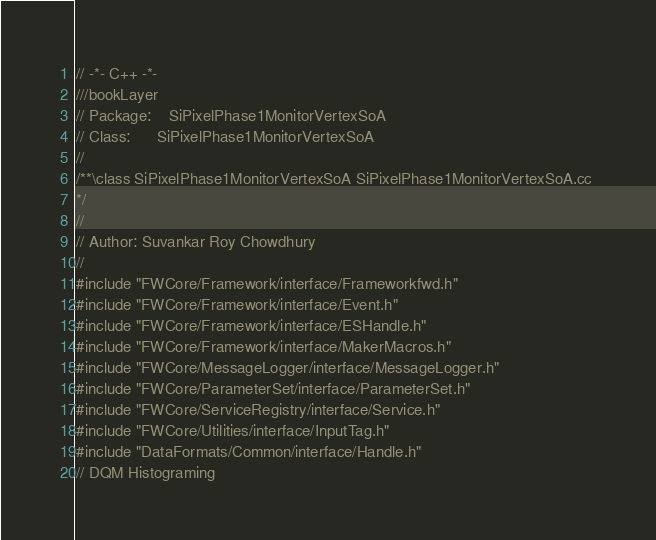Convert code to text. <code><loc_0><loc_0><loc_500><loc_500><_C++_>// -*- C++ -*-
///bookLayer
// Package:    SiPixelPhase1MonitorVertexSoA
// Class:      SiPixelPhase1MonitorVertexSoA
//
/**\class SiPixelPhase1MonitorVertexSoA SiPixelPhase1MonitorVertexSoA.cc 
*/
//
// Author: Suvankar Roy Chowdhury
//
#include "FWCore/Framework/interface/Frameworkfwd.h"
#include "FWCore/Framework/interface/Event.h"
#include "FWCore/Framework/interface/ESHandle.h"
#include "FWCore/Framework/interface/MakerMacros.h"
#include "FWCore/MessageLogger/interface/MessageLogger.h"
#include "FWCore/ParameterSet/interface/ParameterSet.h"
#include "FWCore/ServiceRegistry/interface/Service.h"
#include "FWCore/Utilities/interface/InputTag.h"
#include "DataFormats/Common/interface/Handle.h"
// DQM Histograming</code> 